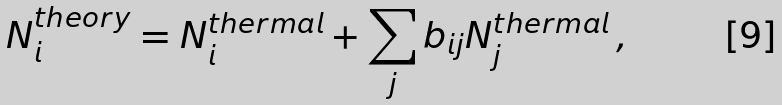<formula> <loc_0><loc_0><loc_500><loc_500>N _ { i } ^ { t h e o r y } = N _ { i } ^ { t h e r m a l } + \sum _ { j } b _ { i j } N _ { j } ^ { t h e r m a l } \, ,</formula> 